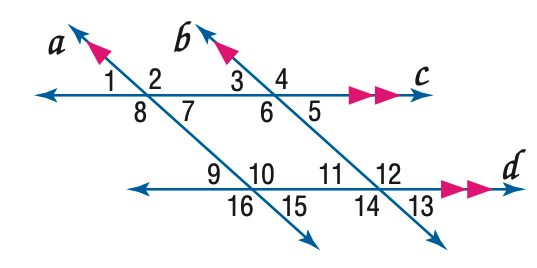Answer the mathemtical geometry problem and directly provide the correct option letter.
Question: In the figure, m \angle 3 = 43. Find the measure of \angle 10.
Choices: A: 117 B: 127 C: 137 D: 147 C 